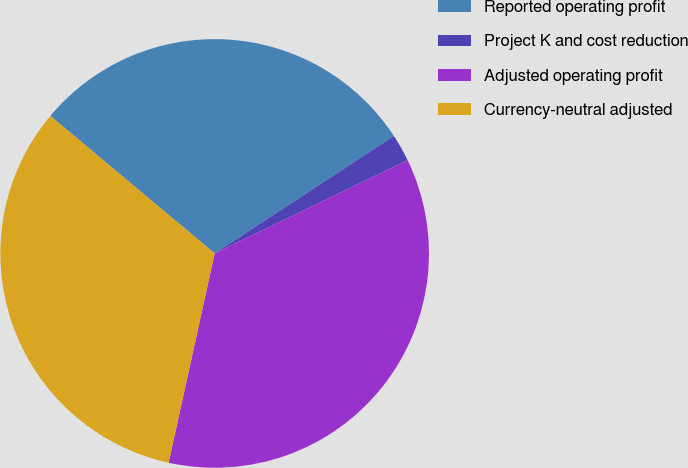Convert chart to OTSL. <chart><loc_0><loc_0><loc_500><loc_500><pie_chart><fcel>Reported operating profit<fcel>Project K and cost reduction<fcel>Adjusted operating profit<fcel>Currency-neutral adjusted<nl><fcel>29.67%<fcel>2.07%<fcel>35.61%<fcel>32.64%<nl></chart> 